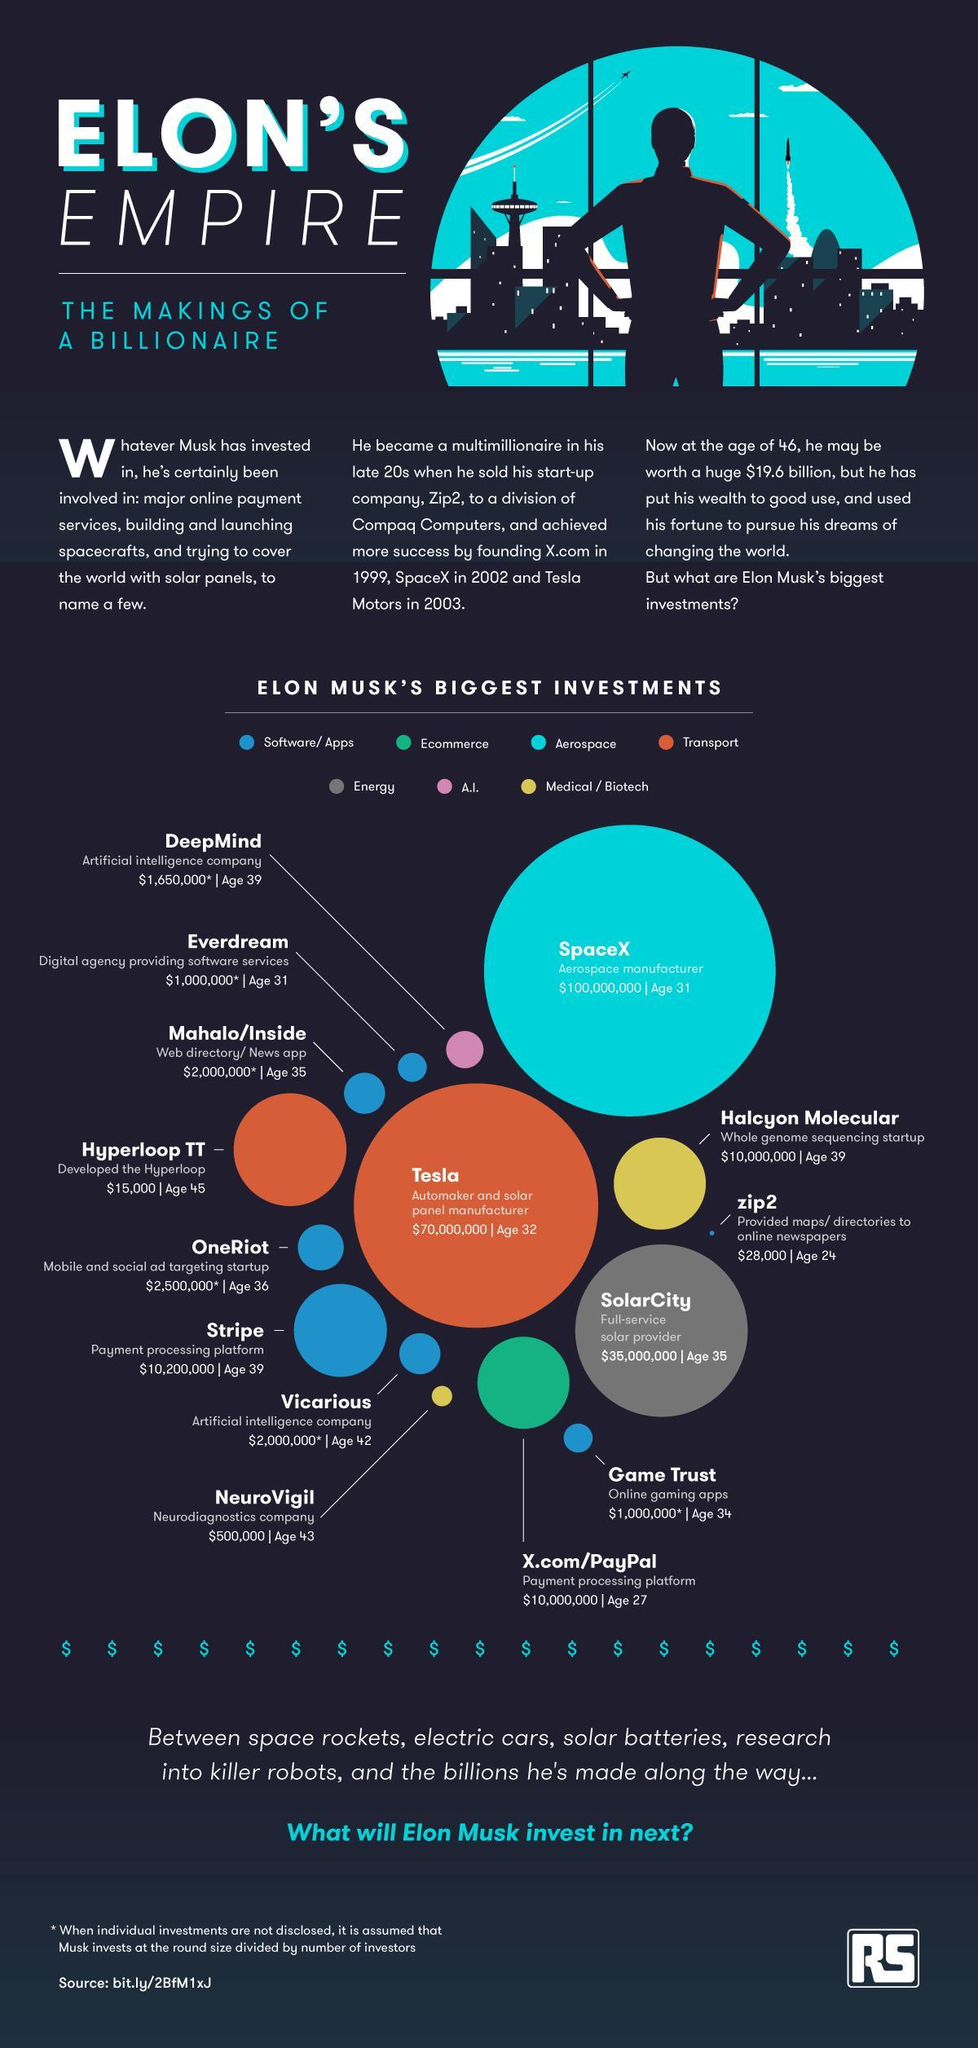Which area has Elon Musk's biggest investment?
Answer the question with a short phrase. Aerospace 